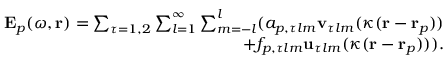<formula> <loc_0><loc_0><loc_500><loc_500>\begin{array} { r } { E _ { p } ( \omega , r ) = \sum _ { \tau = 1 , 2 } \sum _ { l = 1 } ^ { \infty } \sum _ { m = - l } ^ { l } ( a _ { p , \tau l m } v _ { \tau l m } ( \kappa ( r - r _ { p } ) ) } \\ { + f _ { p , \tau l m } u _ { \tau l m } ( \kappa ( r - r _ { p } ) ) ) . } \end{array}</formula> 